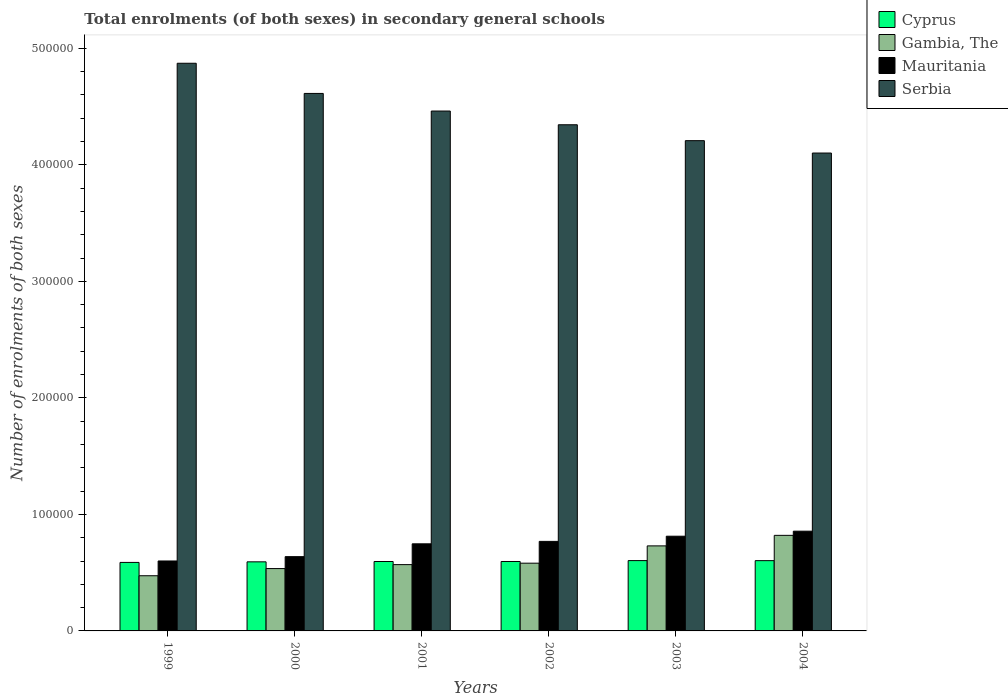How many different coloured bars are there?
Give a very brief answer. 4. How many groups of bars are there?
Your answer should be compact. 6. How many bars are there on the 4th tick from the left?
Offer a terse response. 4. What is the number of enrolments in secondary schools in Mauritania in 2003?
Keep it short and to the point. 8.13e+04. Across all years, what is the maximum number of enrolments in secondary schools in Cyprus?
Ensure brevity in your answer.  6.03e+04. Across all years, what is the minimum number of enrolments in secondary schools in Serbia?
Your answer should be compact. 4.10e+05. What is the total number of enrolments in secondary schools in Cyprus in the graph?
Provide a short and direct response. 3.58e+05. What is the difference between the number of enrolments in secondary schools in Mauritania in 1999 and that in 2000?
Your answer should be very brief. -3706. What is the difference between the number of enrolments in secondary schools in Cyprus in 2000 and the number of enrolments in secondary schools in Serbia in 2004?
Offer a very short reply. -3.51e+05. What is the average number of enrolments in secondary schools in Cyprus per year?
Your answer should be compact. 5.96e+04. In the year 2001, what is the difference between the number of enrolments in secondary schools in Serbia and number of enrolments in secondary schools in Gambia, The?
Ensure brevity in your answer.  3.89e+05. In how many years, is the number of enrolments in secondary schools in Serbia greater than 360000?
Provide a succinct answer. 6. What is the ratio of the number of enrolments in secondary schools in Cyprus in 2000 to that in 2002?
Your answer should be very brief. 1. Is the number of enrolments in secondary schools in Gambia, The in 1999 less than that in 2001?
Provide a succinct answer. Yes. Is the difference between the number of enrolments in secondary schools in Serbia in 2001 and 2003 greater than the difference between the number of enrolments in secondary schools in Gambia, The in 2001 and 2003?
Your answer should be very brief. Yes. What is the difference between the highest and the second highest number of enrolments in secondary schools in Gambia, The?
Provide a succinct answer. 9037. What is the difference between the highest and the lowest number of enrolments in secondary schools in Cyprus?
Provide a succinct answer. 1559. In how many years, is the number of enrolments in secondary schools in Cyprus greater than the average number of enrolments in secondary schools in Cyprus taken over all years?
Your answer should be very brief. 2. Is it the case that in every year, the sum of the number of enrolments in secondary schools in Gambia, The and number of enrolments in secondary schools in Serbia is greater than the sum of number of enrolments in secondary schools in Mauritania and number of enrolments in secondary schools in Cyprus?
Your answer should be very brief. Yes. What does the 4th bar from the left in 2001 represents?
Offer a very short reply. Serbia. What does the 3rd bar from the right in 2002 represents?
Ensure brevity in your answer.  Gambia, The. Are all the bars in the graph horizontal?
Offer a very short reply. No. How many legend labels are there?
Your answer should be compact. 4. What is the title of the graph?
Ensure brevity in your answer.  Total enrolments (of both sexes) in secondary general schools. Does "Small states" appear as one of the legend labels in the graph?
Make the answer very short. No. What is the label or title of the X-axis?
Make the answer very short. Years. What is the label or title of the Y-axis?
Give a very brief answer. Number of enrolments of both sexes. What is the Number of enrolments of both sexes in Cyprus in 1999?
Make the answer very short. 5.88e+04. What is the Number of enrolments of both sexes in Gambia, The in 1999?
Ensure brevity in your answer.  4.74e+04. What is the Number of enrolments of both sexes in Mauritania in 1999?
Give a very brief answer. 6.00e+04. What is the Number of enrolments of both sexes in Serbia in 1999?
Your answer should be very brief. 4.87e+05. What is the Number of enrolments of both sexes in Cyprus in 2000?
Your answer should be very brief. 5.93e+04. What is the Number of enrolments of both sexes of Gambia, The in 2000?
Your answer should be compact. 5.35e+04. What is the Number of enrolments of both sexes of Mauritania in 2000?
Offer a very short reply. 6.37e+04. What is the Number of enrolments of both sexes in Serbia in 2000?
Your response must be concise. 4.61e+05. What is the Number of enrolments of both sexes of Cyprus in 2001?
Your response must be concise. 5.96e+04. What is the Number of enrolments of both sexes of Gambia, The in 2001?
Ensure brevity in your answer.  5.69e+04. What is the Number of enrolments of both sexes of Mauritania in 2001?
Your answer should be compact. 7.47e+04. What is the Number of enrolments of both sexes in Serbia in 2001?
Offer a terse response. 4.46e+05. What is the Number of enrolments of both sexes in Cyprus in 2002?
Ensure brevity in your answer.  5.96e+04. What is the Number of enrolments of both sexes of Gambia, The in 2002?
Your answer should be very brief. 5.81e+04. What is the Number of enrolments of both sexes in Mauritania in 2002?
Your response must be concise. 7.68e+04. What is the Number of enrolments of both sexes of Serbia in 2002?
Keep it short and to the point. 4.34e+05. What is the Number of enrolments of both sexes in Cyprus in 2003?
Your answer should be very brief. 6.03e+04. What is the Number of enrolments of both sexes of Gambia, The in 2003?
Keep it short and to the point. 7.30e+04. What is the Number of enrolments of both sexes in Mauritania in 2003?
Give a very brief answer. 8.13e+04. What is the Number of enrolments of both sexes of Serbia in 2003?
Your answer should be very brief. 4.21e+05. What is the Number of enrolments of both sexes in Cyprus in 2004?
Keep it short and to the point. 6.03e+04. What is the Number of enrolments of both sexes of Gambia, The in 2004?
Offer a terse response. 8.20e+04. What is the Number of enrolments of both sexes of Mauritania in 2004?
Offer a very short reply. 8.56e+04. What is the Number of enrolments of both sexes of Serbia in 2004?
Give a very brief answer. 4.10e+05. Across all years, what is the maximum Number of enrolments of both sexes in Cyprus?
Provide a short and direct response. 6.03e+04. Across all years, what is the maximum Number of enrolments of both sexes of Gambia, The?
Ensure brevity in your answer.  8.20e+04. Across all years, what is the maximum Number of enrolments of both sexes of Mauritania?
Your answer should be compact. 8.56e+04. Across all years, what is the maximum Number of enrolments of both sexes of Serbia?
Your answer should be compact. 4.87e+05. Across all years, what is the minimum Number of enrolments of both sexes in Cyprus?
Your answer should be very brief. 5.88e+04. Across all years, what is the minimum Number of enrolments of both sexes in Gambia, The?
Ensure brevity in your answer.  4.74e+04. Across all years, what is the minimum Number of enrolments of both sexes in Mauritania?
Provide a succinct answer. 6.00e+04. Across all years, what is the minimum Number of enrolments of both sexes in Serbia?
Your answer should be compact. 4.10e+05. What is the total Number of enrolments of both sexes of Cyprus in the graph?
Your answer should be compact. 3.58e+05. What is the total Number of enrolments of both sexes of Gambia, The in the graph?
Your answer should be compact. 3.71e+05. What is the total Number of enrolments of both sexes in Mauritania in the graph?
Offer a very short reply. 4.42e+05. What is the total Number of enrolments of both sexes of Serbia in the graph?
Make the answer very short. 2.66e+06. What is the difference between the Number of enrolments of both sexes of Cyprus in 1999 and that in 2000?
Provide a succinct answer. -496. What is the difference between the Number of enrolments of both sexes in Gambia, The in 1999 and that in 2000?
Your answer should be very brief. -6152. What is the difference between the Number of enrolments of both sexes of Mauritania in 1999 and that in 2000?
Your answer should be very brief. -3706. What is the difference between the Number of enrolments of both sexes in Serbia in 1999 and that in 2000?
Ensure brevity in your answer.  2.59e+04. What is the difference between the Number of enrolments of both sexes in Cyprus in 1999 and that in 2001?
Your response must be concise. -779. What is the difference between the Number of enrolments of both sexes of Gambia, The in 1999 and that in 2001?
Make the answer very short. -9535. What is the difference between the Number of enrolments of both sexes of Mauritania in 1999 and that in 2001?
Your response must be concise. -1.47e+04. What is the difference between the Number of enrolments of both sexes in Serbia in 1999 and that in 2001?
Keep it short and to the point. 4.10e+04. What is the difference between the Number of enrolments of both sexes in Cyprus in 1999 and that in 2002?
Offer a terse response. -792. What is the difference between the Number of enrolments of both sexes in Gambia, The in 1999 and that in 2002?
Offer a terse response. -1.08e+04. What is the difference between the Number of enrolments of both sexes of Mauritania in 1999 and that in 2002?
Offer a very short reply. -1.68e+04. What is the difference between the Number of enrolments of both sexes in Serbia in 1999 and that in 2002?
Provide a short and direct response. 5.28e+04. What is the difference between the Number of enrolments of both sexes of Cyprus in 1999 and that in 2003?
Provide a succinct answer. -1559. What is the difference between the Number of enrolments of both sexes in Gambia, The in 1999 and that in 2003?
Make the answer very short. -2.56e+04. What is the difference between the Number of enrolments of both sexes of Mauritania in 1999 and that in 2003?
Give a very brief answer. -2.12e+04. What is the difference between the Number of enrolments of both sexes in Serbia in 1999 and that in 2003?
Give a very brief answer. 6.64e+04. What is the difference between the Number of enrolments of both sexes of Cyprus in 1999 and that in 2004?
Ensure brevity in your answer.  -1520. What is the difference between the Number of enrolments of both sexes of Gambia, The in 1999 and that in 2004?
Your answer should be compact. -3.47e+04. What is the difference between the Number of enrolments of both sexes in Mauritania in 1999 and that in 2004?
Give a very brief answer. -2.56e+04. What is the difference between the Number of enrolments of both sexes in Serbia in 1999 and that in 2004?
Provide a succinct answer. 7.70e+04. What is the difference between the Number of enrolments of both sexes of Cyprus in 2000 and that in 2001?
Your answer should be compact. -283. What is the difference between the Number of enrolments of both sexes in Gambia, The in 2000 and that in 2001?
Make the answer very short. -3383. What is the difference between the Number of enrolments of both sexes in Mauritania in 2000 and that in 2001?
Your response must be concise. -1.10e+04. What is the difference between the Number of enrolments of both sexes of Serbia in 2000 and that in 2001?
Ensure brevity in your answer.  1.51e+04. What is the difference between the Number of enrolments of both sexes of Cyprus in 2000 and that in 2002?
Make the answer very short. -296. What is the difference between the Number of enrolments of both sexes in Gambia, The in 2000 and that in 2002?
Give a very brief answer. -4617. What is the difference between the Number of enrolments of both sexes in Mauritania in 2000 and that in 2002?
Give a very brief answer. -1.31e+04. What is the difference between the Number of enrolments of both sexes of Serbia in 2000 and that in 2002?
Offer a terse response. 2.69e+04. What is the difference between the Number of enrolments of both sexes of Cyprus in 2000 and that in 2003?
Provide a succinct answer. -1063. What is the difference between the Number of enrolments of both sexes of Gambia, The in 2000 and that in 2003?
Provide a succinct answer. -1.95e+04. What is the difference between the Number of enrolments of both sexes in Mauritania in 2000 and that in 2003?
Provide a short and direct response. -1.75e+04. What is the difference between the Number of enrolments of both sexes in Serbia in 2000 and that in 2003?
Your answer should be very brief. 4.05e+04. What is the difference between the Number of enrolments of both sexes in Cyprus in 2000 and that in 2004?
Your answer should be compact. -1024. What is the difference between the Number of enrolments of both sexes of Gambia, The in 2000 and that in 2004?
Offer a terse response. -2.85e+04. What is the difference between the Number of enrolments of both sexes in Mauritania in 2000 and that in 2004?
Offer a very short reply. -2.19e+04. What is the difference between the Number of enrolments of both sexes of Serbia in 2000 and that in 2004?
Provide a succinct answer. 5.12e+04. What is the difference between the Number of enrolments of both sexes in Cyprus in 2001 and that in 2002?
Provide a short and direct response. -13. What is the difference between the Number of enrolments of both sexes in Gambia, The in 2001 and that in 2002?
Provide a short and direct response. -1234. What is the difference between the Number of enrolments of both sexes of Mauritania in 2001 and that in 2002?
Give a very brief answer. -2095. What is the difference between the Number of enrolments of both sexes of Serbia in 2001 and that in 2002?
Your answer should be compact. 1.18e+04. What is the difference between the Number of enrolments of both sexes in Cyprus in 2001 and that in 2003?
Your response must be concise. -780. What is the difference between the Number of enrolments of both sexes in Gambia, The in 2001 and that in 2003?
Offer a very short reply. -1.61e+04. What is the difference between the Number of enrolments of both sexes in Mauritania in 2001 and that in 2003?
Your response must be concise. -6536. What is the difference between the Number of enrolments of both sexes of Serbia in 2001 and that in 2003?
Your answer should be very brief. 2.54e+04. What is the difference between the Number of enrolments of both sexes of Cyprus in 2001 and that in 2004?
Offer a terse response. -741. What is the difference between the Number of enrolments of both sexes of Gambia, The in 2001 and that in 2004?
Make the answer very short. -2.51e+04. What is the difference between the Number of enrolments of both sexes of Mauritania in 2001 and that in 2004?
Offer a terse response. -1.08e+04. What is the difference between the Number of enrolments of both sexes in Serbia in 2001 and that in 2004?
Keep it short and to the point. 3.60e+04. What is the difference between the Number of enrolments of both sexes in Cyprus in 2002 and that in 2003?
Your answer should be compact. -767. What is the difference between the Number of enrolments of both sexes in Gambia, The in 2002 and that in 2003?
Give a very brief answer. -1.48e+04. What is the difference between the Number of enrolments of both sexes of Mauritania in 2002 and that in 2003?
Provide a succinct answer. -4441. What is the difference between the Number of enrolments of both sexes of Serbia in 2002 and that in 2003?
Your answer should be very brief. 1.36e+04. What is the difference between the Number of enrolments of both sexes in Cyprus in 2002 and that in 2004?
Ensure brevity in your answer.  -728. What is the difference between the Number of enrolments of both sexes of Gambia, The in 2002 and that in 2004?
Your response must be concise. -2.39e+04. What is the difference between the Number of enrolments of both sexes of Mauritania in 2002 and that in 2004?
Your answer should be very brief. -8751. What is the difference between the Number of enrolments of both sexes in Serbia in 2002 and that in 2004?
Provide a short and direct response. 2.43e+04. What is the difference between the Number of enrolments of both sexes in Cyprus in 2003 and that in 2004?
Make the answer very short. 39. What is the difference between the Number of enrolments of both sexes of Gambia, The in 2003 and that in 2004?
Your answer should be very brief. -9037. What is the difference between the Number of enrolments of both sexes in Mauritania in 2003 and that in 2004?
Make the answer very short. -4310. What is the difference between the Number of enrolments of both sexes in Serbia in 2003 and that in 2004?
Offer a very short reply. 1.06e+04. What is the difference between the Number of enrolments of both sexes of Cyprus in 1999 and the Number of enrolments of both sexes of Gambia, The in 2000?
Offer a terse response. 5279. What is the difference between the Number of enrolments of both sexes in Cyprus in 1999 and the Number of enrolments of both sexes in Mauritania in 2000?
Make the answer very short. -4946. What is the difference between the Number of enrolments of both sexes in Cyprus in 1999 and the Number of enrolments of both sexes in Serbia in 2000?
Your response must be concise. -4.02e+05. What is the difference between the Number of enrolments of both sexes of Gambia, The in 1999 and the Number of enrolments of both sexes of Mauritania in 2000?
Give a very brief answer. -1.64e+04. What is the difference between the Number of enrolments of both sexes in Gambia, The in 1999 and the Number of enrolments of both sexes in Serbia in 2000?
Provide a succinct answer. -4.14e+05. What is the difference between the Number of enrolments of both sexes of Mauritania in 1999 and the Number of enrolments of both sexes of Serbia in 2000?
Your answer should be very brief. -4.01e+05. What is the difference between the Number of enrolments of both sexes in Cyprus in 1999 and the Number of enrolments of both sexes in Gambia, The in 2001?
Make the answer very short. 1896. What is the difference between the Number of enrolments of both sexes in Cyprus in 1999 and the Number of enrolments of both sexes in Mauritania in 2001?
Make the answer very short. -1.60e+04. What is the difference between the Number of enrolments of both sexes of Cyprus in 1999 and the Number of enrolments of both sexes of Serbia in 2001?
Your answer should be compact. -3.87e+05. What is the difference between the Number of enrolments of both sexes in Gambia, The in 1999 and the Number of enrolments of both sexes in Mauritania in 2001?
Provide a short and direct response. -2.74e+04. What is the difference between the Number of enrolments of both sexes of Gambia, The in 1999 and the Number of enrolments of both sexes of Serbia in 2001?
Ensure brevity in your answer.  -3.99e+05. What is the difference between the Number of enrolments of both sexes of Mauritania in 1999 and the Number of enrolments of both sexes of Serbia in 2001?
Your response must be concise. -3.86e+05. What is the difference between the Number of enrolments of both sexes in Cyprus in 1999 and the Number of enrolments of both sexes in Gambia, The in 2002?
Your answer should be very brief. 662. What is the difference between the Number of enrolments of both sexes of Cyprus in 1999 and the Number of enrolments of both sexes of Mauritania in 2002?
Give a very brief answer. -1.80e+04. What is the difference between the Number of enrolments of both sexes in Cyprus in 1999 and the Number of enrolments of both sexes in Serbia in 2002?
Make the answer very short. -3.76e+05. What is the difference between the Number of enrolments of both sexes in Gambia, The in 1999 and the Number of enrolments of both sexes in Mauritania in 2002?
Give a very brief answer. -2.95e+04. What is the difference between the Number of enrolments of both sexes of Gambia, The in 1999 and the Number of enrolments of both sexes of Serbia in 2002?
Offer a terse response. -3.87e+05. What is the difference between the Number of enrolments of both sexes of Mauritania in 1999 and the Number of enrolments of both sexes of Serbia in 2002?
Make the answer very short. -3.74e+05. What is the difference between the Number of enrolments of both sexes of Cyprus in 1999 and the Number of enrolments of both sexes of Gambia, The in 2003?
Keep it short and to the point. -1.42e+04. What is the difference between the Number of enrolments of both sexes in Cyprus in 1999 and the Number of enrolments of both sexes in Mauritania in 2003?
Provide a succinct answer. -2.25e+04. What is the difference between the Number of enrolments of both sexes in Cyprus in 1999 and the Number of enrolments of both sexes in Serbia in 2003?
Ensure brevity in your answer.  -3.62e+05. What is the difference between the Number of enrolments of both sexes of Gambia, The in 1999 and the Number of enrolments of both sexes of Mauritania in 2003?
Ensure brevity in your answer.  -3.39e+04. What is the difference between the Number of enrolments of both sexes of Gambia, The in 1999 and the Number of enrolments of both sexes of Serbia in 2003?
Your answer should be very brief. -3.73e+05. What is the difference between the Number of enrolments of both sexes of Mauritania in 1999 and the Number of enrolments of both sexes of Serbia in 2003?
Your response must be concise. -3.61e+05. What is the difference between the Number of enrolments of both sexes in Cyprus in 1999 and the Number of enrolments of both sexes in Gambia, The in 2004?
Ensure brevity in your answer.  -2.32e+04. What is the difference between the Number of enrolments of both sexes in Cyprus in 1999 and the Number of enrolments of both sexes in Mauritania in 2004?
Provide a succinct answer. -2.68e+04. What is the difference between the Number of enrolments of both sexes in Cyprus in 1999 and the Number of enrolments of both sexes in Serbia in 2004?
Make the answer very short. -3.51e+05. What is the difference between the Number of enrolments of both sexes of Gambia, The in 1999 and the Number of enrolments of both sexes of Mauritania in 2004?
Offer a very short reply. -3.82e+04. What is the difference between the Number of enrolments of both sexes in Gambia, The in 1999 and the Number of enrolments of both sexes in Serbia in 2004?
Provide a succinct answer. -3.63e+05. What is the difference between the Number of enrolments of both sexes of Mauritania in 1999 and the Number of enrolments of both sexes of Serbia in 2004?
Give a very brief answer. -3.50e+05. What is the difference between the Number of enrolments of both sexes in Cyprus in 2000 and the Number of enrolments of both sexes in Gambia, The in 2001?
Ensure brevity in your answer.  2392. What is the difference between the Number of enrolments of both sexes of Cyprus in 2000 and the Number of enrolments of both sexes of Mauritania in 2001?
Your response must be concise. -1.55e+04. What is the difference between the Number of enrolments of both sexes in Cyprus in 2000 and the Number of enrolments of both sexes in Serbia in 2001?
Keep it short and to the point. -3.87e+05. What is the difference between the Number of enrolments of both sexes of Gambia, The in 2000 and the Number of enrolments of both sexes of Mauritania in 2001?
Offer a very short reply. -2.12e+04. What is the difference between the Number of enrolments of both sexes of Gambia, The in 2000 and the Number of enrolments of both sexes of Serbia in 2001?
Ensure brevity in your answer.  -3.93e+05. What is the difference between the Number of enrolments of both sexes in Mauritania in 2000 and the Number of enrolments of both sexes in Serbia in 2001?
Provide a short and direct response. -3.82e+05. What is the difference between the Number of enrolments of both sexes in Cyprus in 2000 and the Number of enrolments of both sexes in Gambia, The in 2002?
Provide a short and direct response. 1158. What is the difference between the Number of enrolments of both sexes of Cyprus in 2000 and the Number of enrolments of both sexes of Mauritania in 2002?
Your response must be concise. -1.76e+04. What is the difference between the Number of enrolments of both sexes of Cyprus in 2000 and the Number of enrolments of both sexes of Serbia in 2002?
Offer a terse response. -3.75e+05. What is the difference between the Number of enrolments of both sexes in Gambia, The in 2000 and the Number of enrolments of both sexes in Mauritania in 2002?
Provide a succinct answer. -2.33e+04. What is the difference between the Number of enrolments of both sexes of Gambia, The in 2000 and the Number of enrolments of both sexes of Serbia in 2002?
Offer a terse response. -3.81e+05. What is the difference between the Number of enrolments of both sexes in Mauritania in 2000 and the Number of enrolments of both sexes in Serbia in 2002?
Offer a very short reply. -3.71e+05. What is the difference between the Number of enrolments of both sexes in Cyprus in 2000 and the Number of enrolments of both sexes in Gambia, The in 2003?
Your answer should be compact. -1.37e+04. What is the difference between the Number of enrolments of both sexes in Cyprus in 2000 and the Number of enrolments of both sexes in Mauritania in 2003?
Offer a very short reply. -2.20e+04. What is the difference between the Number of enrolments of both sexes of Cyprus in 2000 and the Number of enrolments of both sexes of Serbia in 2003?
Provide a succinct answer. -3.61e+05. What is the difference between the Number of enrolments of both sexes in Gambia, The in 2000 and the Number of enrolments of both sexes in Mauritania in 2003?
Keep it short and to the point. -2.78e+04. What is the difference between the Number of enrolments of both sexes in Gambia, The in 2000 and the Number of enrolments of both sexes in Serbia in 2003?
Offer a very short reply. -3.67e+05. What is the difference between the Number of enrolments of both sexes of Mauritania in 2000 and the Number of enrolments of both sexes of Serbia in 2003?
Provide a succinct answer. -3.57e+05. What is the difference between the Number of enrolments of both sexes of Cyprus in 2000 and the Number of enrolments of both sexes of Gambia, The in 2004?
Offer a terse response. -2.27e+04. What is the difference between the Number of enrolments of both sexes of Cyprus in 2000 and the Number of enrolments of both sexes of Mauritania in 2004?
Your answer should be very brief. -2.63e+04. What is the difference between the Number of enrolments of both sexes in Cyprus in 2000 and the Number of enrolments of both sexes in Serbia in 2004?
Your response must be concise. -3.51e+05. What is the difference between the Number of enrolments of both sexes of Gambia, The in 2000 and the Number of enrolments of both sexes of Mauritania in 2004?
Offer a very short reply. -3.21e+04. What is the difference between the Number of enrolments of both sexes of Gambia, The in 2000 and the Number of enrolments of both sexes of Serbia in 2004?
Give a very brief answer. -3.57e+05. What is the difference between the Number of enrolments of both sexes in Mauritania in 2000 and the Number of enrolments of both sexes in Serbia in 2004?
Ensure brevity in your answer.  -3.46e+05. What is the difference between the Number of enrolments of both sexes of Cyprus in 2001 and the Number of enrolments of both sexes of Gambia, The in 2002?
Your response must be concise. 1441. What is the difference between the Number of enrolments of both sexes in Cyprus in 2001 and the Number of enrolments of both sexes in Mauritania in 2002?
Your answer should be very brief. -1.73e+04. What is the difference between the Number of enrolments of both sexes of Cyprus in 2001 and the Number of enrolments of both sexes of Serbia in 2002?
Your response must be concise. -3.75e+05. What is the difference between the Number of enrolments of both sexes of Gambia, The in 2001 and the Number of enrolments of both sexes of Mauritania in 2002?
Give a very brief answer. -1.99e+04. What is the difference between the Number of enrolments of both sexes of Gambia, The in 2001 and the Number of enrolments of both sexes of Serbia in 2002?
Offer a very short reply. -3.77e+05. What is the difference between the Number of enrolments of both sexes in Mauritania in 2001 and the Number of enrolments of both sexes in Serbia in 2002?
Keep it short and to the point. -3.60e+05. What is the difference between the Number of enrolments of both sexes of Cyprus in 2001 and the Number of enrolments of both sexes of Gambia, The in 2003?
Your answer should be compact. -1.34e+04. What is the difference between the Number of enrolments of both sexes in Cyprus in 2001 and the Number of enrolments of both sexes in Mauritania in 2003?
Keep it short and to the point. -2.17e+04. What is the difference between the Number of enrolments of both sexes in Cyprus in 2001 and the Number of enrolments of both sexes in Serbia in 2003?
Make the answer very short. -3.61e+05. What is the difference between the Number of enrolments of both sexes of Gambia, The in 2001 and the Number of enrolments of both sexes of Mauritania in 2003?
Make the answer very short. -2.44e+04. What is the difference between the Number of enrolments of both sexes of Gambia, The in 2001 and the Number of enrolments of both sexes of Serbia in 2003?
Offer a very short reply. -3.64e+05. What is the difference between the Number of enrolments of both sexes in Mauritania in 2001 and the Number of enrolments of both sexes in Serbia in 2003?
Provide a succinct answer. -3.46e+05. What is the difference between the Number of enrolments of both sexes in Cyprus in 2001 and the Number of enrolments of both sexes in Gambia, The in 2004?
Provide a succinct answer. -2.24e+04. What is the difference between the Number of enrolments of both sexes of Cyprus in 2001 and the Number of enrolments of both sexes of Mauritania in 2004?
Your answer should be compact. -2.60e+04. What is the difference between the Number of enrolments of both sexes in Cyprus in 2001 and the Number of enrolments of both sexes in Serbia in 2004?
Provide a succinct answer. -3.51e+05. What is the difference between the Number of enrolments of both sexes in Gambia, The in 2001 and the Number of enrolments of both sexes in Mauritania in 2004?
Your answer should be compact. -2.87e+04. What is the difference between the Number of enrolments of both sexes of Gambia, The in 2001 and the Number of enrolments of both sexes of Serbia in 2004?
Keep it short and to the point. -3.53e+05. What is the difference between the Number of enrolments of both sexes in Mauritania in 2001 and the Number of enrolments of both sexes in Serbia in 2004?
Ensure brevity in your answer.  -3.35e+05. What is the difference between the Number of enrolments of both sexes in Cyprus in 2002 and the Number of enrolments of both sexes in Gambia, The in 2003?
Your response must be concise. -1.34e+04. What is the difference between the Number of enrolments of both sexes in Cyprus in 2002 and the Number of enrolments of both sexes in Mauritania in 2003?
Your answer should be compact. -2.17e+04. What is the difference between the Number of enrolments of both sexes in Cyprus in 2002 and the Number of enrolments of both sexes in Serbia in 2003?
Give a very brief answer. -3.61e+05. What is the difference between the Number of enrolments of both sexes of Gambia, The in 2002 and the Number of enrolments of both sexes of Mauritania in 2003?
Your answer should be compact. -2.32e+04. What is the difference between the Number of enrolments of both sexes of Gambia, The in 2002 and the Number of enrolments of both sexes of Serbia in 2003?
Provide a short and direct response. -3.63e+05. What is the difference between the Number of enrolments of both sexes in Mauritania in 2002 and the Number of enrolments of both sexes in Serbia in 2003?
Keep it short and to the point. -3.44e+05. What is the difference between the Number of enrolments of both sexes in Cyprus in 2002 and the Number of enrolments of both sexes in Gambia, The in 2004?
Provide a succinct answer. -2.24e+04. What is the difference between the Number of enrolments of both sexes in Cyprus in 2002 and the Number of enrolments of both sexes in Mauritania in 2004?
Offer a very short reply. -2.60e+04. What is the difference between the Number of enrolments of both sexes of Cyprus in 2002 and the Number of enrolments of both sexes of Serbia in 2004?
Ensure brevity in your answer.  -3.51e+05. What is the difference between the Number of enrolments of both sexes in Gambia, The in 2002 and the Number of enrolments of both sexes in Mauritania in 2004?
Make the answer very short. -2.75e+04. What is the difference between the Number of enrolments of both sexes in Gambia, The in 2002 and the Number of enrolments of both sexes in Serbia in 2004?
Give a very brief answer. -3.52e+05. What is the difference between the Number of enrolments of both sexes in Mauritania in 2002 and the Number of enrolments of both sexes in Serbia in 2004?
Provide a short and direct response. -3.33e+05. What is the difference between the Number of enrolments of both sexes of Cyprus in 2003 and the Number of enrolments of both sexes of Gambia, The in 2004?
Offer a terse response. -2.17e+04. What is the difference between the Number of enrolments of both sexes of Cyprus in 2003 and the Number of enrolments of both sexes of Mauritania in 2004?
Your response must be concise. -2.52e+04. What is the difference between the Number of enrolments of both sexes in Cyprus in 2003 and the Number of enrolments of both sexes in Serbia in 2004?
Your answer should be very brief. -3.50e+05. What is the difference between the Number of enrolments of both sexes of Gambia, The in 2003 and the Number of enrolments of both sexes of Mauritania in 2004?
Give a very brief answer. -1.26e+04. What is the difference between the Number of enrolments of both sexes in Gambia, The in 2003 and the Number of enrolments of both sexes in Serbia in 2004?
Provide a short and direct response. -3.37e+05. What is the difference between the Number of enrolments of both sexes in Mauritania in 2003 and the Number of enrolments of both sexes in Serbia in 2004?
Ensure brevity in your answer.  -3.29e+05. What is the average Number of enrolments of both sexes of Cyprus per year?
Provide a succinct answer. 5.96e+04. What is the average Number of enrolments of both sexes of Gambia, The per year?
Your answer should be very brief. 6.18e+04. What is the average Number of enrolments of both sexes in Mauritania per year?
Provide a succinct answer. 7.37e+04. What is the average Number of enrolments of both sexes of Serbia per year?
Your answer should be very brief. 4.43e+05. In the year 1999, what is the difference between the Number of enrolments of both sexes in Cyprus and Number of enrolments of both sexes in Gambia, The?
Keep it short and to the point. 1.14e+04. In the year 1999, what is the difference between the Number of enrolments of both sexes in Cyprus and Number of enrolments of both sexes in Mauritania?
Provide a short and direct response. -1240. In the year 1999, what is the difference between the Number of enrolments of both sexes in Cyprus and Number of enrolments of both sexes in Serbia?
Offer a very short reply. -4.28e+05. In the year 1999, what is the difference between the Number of enrolments of both sexes of Gambia, The and Number of enrolments of both sexes of Mauritania?
Your answer should be very brief. -1.27e+04. In the year 1999, what is the difference between the Number of enrolments of both sexes in Gambia, The and Number of enrolments of both sexes in Serbia?
Your response must be concise. -4.40e+05. In the year 1999, what is the difference between the Number of enrolments of both sexes in Mauritania and Number of enrolments of both sexes in Serbia?
Provide a succinct answer. -4.27e+05. In the year 2000, what is the difference between the Number of enrolments of both sexes in Cyprus and Number of enrolments of both sexes in Gambia, The?
Offer a very short reply. 5775. In the year 2000, what is the difference between the Number of enrolments of both sexes in Cyprus and Number of enrolments of both sexes in Mauritania?
Your response must be concise. -4450. In the year 2000, what is the difference between the Number of enrolments of both sexes of Cyprus and Number of enrolments of both sexes of Serbia?
Provide a short and direct response. -4.02e+05. In the year 2000, what is the difference between the Number of enrolments of both sexes of Gambia, The and Number of enrolments of both sexes of Mauritania?
Provide a succinct answer. -1.02e+04. In the year 2000, what is the difference between the Number of enrolments of both sexes of Gambia, The and Number of enrolments of both sexes of Serbia?
Make the answer very short. -4.08e+05. In the year 2000, what is the difference between the Number of enrolments of both sexes of Mauritania and Number of enrolments of both sexes of Serbia?
Provide a succinct answer. -3.98e+05. In the year 2001, what is the difference between the Number of enrolments of both sexes of Cyprus and Number of enrolments of both sexes of Gambia, The?
Offer a very short reply. 2675. In the year 2001, what is the difference between the Number of enrolments of both sexes in Cyprus and Number of enrolments of both sexes in Mauritania?
Offer a terse response. -1.52e+04. In the year 2001, what is the difference between the Number of enrolments of both sexes of Cyprus and Number of enrolments of both sexes of Serbia?
Offer a very short reply. -3.87e+05. In the year 2001, what is the difference between the Number of enrolments of both sexes in Gambia, The and Number of enrolments of both sexes in Mauritania?
Provide a succinct answer. -1.78e+04. In the year 2001, what is the difference between the Number of enrolments of both sexes of Gambia, The and Number of enrolments of both sexes of Serbia?
Your answer should be very brief. -3.89e+05. In the year 2001, what is the difference between the Number of enrolments of both sexes of Mauritania and Number of enrolments of both sexes of Serbia?
Offer a very short reply. -3.71e+05. In the year 2002, what is the difference between the Number of enrolments of both sexes of Cyprus and Number of enrolments of both sexes of Gambia, The?
Provide a succinct answer. 1454. In the year 2002, what is the difference between the Number of enrolments of both sexes of Cyprus and Number of enrolments of both sexes of Mauritania?
Keep it short and to the point. -1.73e+04. In the year 2002, what is the difference between the Number of enrolments of both sexes in Cyprus and Number of enrolments of both sexes in Serbia?
Ensure brevity in your answer.  -3.75e+05. In the year 2002, what is the difference between the Number of enrolments of both sexes of Gambia, The and Number of enrolments of both sexes of Mauritania?
Offer a terse response. -1.87e+04. In the year 2002, what is the difference between the Number of enrolments of both sexes in Gambia, The and Number of enrolments of both sexes in Serbia?
Your answer should be compact. -3.76e+05. In the year 2002, what is the difference between the Number of enrolments of both sexes of Mauritania and Number of enrolments of both sexes of Serbia?
Provide a succinct answer. -3.58e+05. In the year 2003, what is the difference between the Number of enrolments of both sexes of Cyprus and Number of enrolments of both sexes of Gambia, The?
Keep it short and to the point. -1.26e+04. In the year 2003, what is the difference between the Number of enrolments of both sexes in Cyprus and Number of enrolments of both sexes in Mauritania?
Offer a very short reply. -2.09e+04. In the year 2003, what is the difference between the Number of enrolments of both sexes in Cyprus and Number of enrolments of both sexes in Serbia?
Your response must be concise. -3.60e+05. In the year 2003, what is the difference between the Number of enrolments of both sexes in Gambia, The and Number of enrolments of both sexes in Mauritania?
Your response must be concise. -8301. In the year 2003, what is the difference between the Number of enrolments of both sexes of Gambia, The and Number of enrolments of both sexes of Serbia?
Give a very brief answer. -3.48e+05. In the year 2003, what is the difference between the Number of enrolments of both sexes in Mauritania and Number of enrolments of both sexes in Serbia?
Your answer should be very brief. -3.39e+05. In the year 2004, what is the difference between the Number of enrolments of both sexes in Cyprus and Number of enrolments of both sexes in Gambia, The?
Your answer should be compact. -2.17e+04. In the year 2004, what is the difference between the Number of enrolments of both sexes of Cyprus and Number of enrolments of both sexes of Mauritania?
Provide a succinct answer. -2.53e+04. In the year 2004, what is the difference between the Number of enrolments of both sexes of Cyprus and Number of enrolments of both sexes of Serbia?
Keep it short and to the point. -3.50e+05. In the year 2004, what is the difference between the Number of enrolments of both sexes of Gambia, The and Number of enrolments of both sexes of Mauritania?
Offer a very short reply. -3574. In the year 2004, what is the difference between the Number of enrolments of both sexes of Gambia, The and Number of enrolments of both sexes of Serbia?
Your response must be concise. -3.28e+05. In the year 2004, what is the difference between the Number of enrolments of both sexes in Mauritania and Number of enrolments of both sexes in Serbia?
Offer a terse response. -3.25e+05. What is the ratio of the Number of enrolments of both sexes in Cyprus in 1999 to that in 2000?
Keep it short and to the point. 0.99. What is the ratio of the Number of enrolments of both sexes in Gambia, The in 1999 to that in 2000?
Your response must be concise. 0.89. What is the ratio of the Number of enrolments of both sexes of Mauritania in 1999 to that in 2000?
Your response must be concise. 0.94. What is the ratio of the Number of enrolments of both sexes in Serbia in 1999 to that in 2000?
Your response must be concise. 1.06. What is the ratio of the Number of enrolments of both sexes of Cyprus in 1999 to that in 2001?
Provide a succinct answer. 0.99. What is the ratio of the Number of enrolments of both sexes of Gambia, The in 1999 to that in 2001?
Provide a short and direct response. 0.83. What is the ratio of the Number of enrolments of both sexes in Mauritania in 1999 to that in 2001?
Offer a very short reply. 0.8. What is the ratio of the Number of enrolments of both sexes in Serbia in 1999 to that in 2001?
Your response must be concise. 1.09. What is the ratio of the Number of enrolments of both sexes of Cyprus in 1999 to that in 2002?
Give a very brief answer. 0.99. What is the ratio of the Number of enrolments of both sexes in Gambia, The in 1999 to that in 2002?
Make the answer very short. 0.81. What is the ratio of the Number of enrolments of both sexes in Mauritania in 1999 to that in 2002?
Offer a terse response. 0.78. What is the ratio of the Number of enrolments of both sexes in Serbia in 1999 to that in 2002?
Provide a short and direct response. 1.12. What is the ratio of the Number of enrolments of both sexes in Cyprus in 1999 to that in 2003?
Provide a short and direct response. 0.97. What is the ratio of the Number of enrolments of both sexes in Gambia, The in 1999 to that in 2003?
Offer a very short reply. 0.65. What is the ratio of the Number of enrolments of both sexes in Mauritania in 1999 to that in 2003?
Keep it short and to the point. 0.74. What is the ratio of the Number of enrolments of both sexes of Serbia in 1999 to that in 2003?
Provide a short and direct response. 1.16. What is the ratio of the Number of enrolments of both sexes in Cyprus in 1999 to that in 2004?
Make the answer very short. 0.97. What is the ratio of the Number of enrolments of both sexes in Gambia, The in 1999 to that in 2004?
Give a very brief answer. 0.58. What is the ratio of the Number of enrolments of both sexes of Mauritania in 1999 to that in 2004?
Provide a short and direct response. 0.7. What is the ratio of the Number of enrolments of both sexes of Serbia in 1999 to that in 2004?
Offer a terse response. 1.19. What is the ratio of the Number of enrolments of both sexes in Cyprus in 2000 to that in 2001?
Keep it short and to the point. 1. What is the ratio of the Number of enrolments of both sexes in Gambia, The in 2000 to that in 2001?
Provide a succinct answer. 0.94. What is the ratio of the Number of enrolments of both sexes in Mauritania in 2000 to that in 2001?
Ensure brevity in your answer.  0.85. What is the ratio of the Number of enrolments of both sexes in Serbia in 2000 to that in 2001?
Your answer should be very brief. 1.03. What is the ratio of the Number of enrolments of both sexes in Gambia, The in 2000 to that in 2002?
Ensure brevity in your answer.  0.92. What is the ratio of the Number of enrolments of both sexes in Mauritania in 2000 to that in 2002?
Offer a terse response. 0.83. What is the ratio of the Number of enrolments of both sexes in Serbia in 2000 to that in 2002?
Ensure brevity in your answer.  1.06. What is the ratio of the Number of enrolments of both sexes in Cyprus in 2000 to that in 2003?
Provide a succinct answer. 0.98. What is the ratio of the Number of enrolments of both sexes in Gambia, The in 2000 to that in 2003?
Your answer should be compact. 0.73. What is the ratio of the Number of enrolments of both sexes in Mauritania in 2000 to that in 2003?
Your answer should be compact. 0.78. What is the ratio of the Number of enrolments of both sexes of Serbia in 2000 to that in 2003?
Offer a terse response. 1.1. What is the ratio of the Number of enrolments of both sexes in Gambia, The in 2000 to that in 2004?
Ensure brevity in your answer.  0.65. What is the ratio of the Number of enrolments of both sexes in Mauritania in 2000 to that in 2004?
Your response must be concise. 0.74. What is the ratio of the Number of enrolments of both sexes in Serbia in 2000 to that in 2004?
Your answer should be very brief. 1.12. What is the ratio of the Number of enrolments of both sexes of Gambia, The in 2001 to that in 2002?
Your response must be concise. 0.98. What is the ratio of the Number of enrolments of both sexes in Mauritania in 2001 to that in 2002?
Your answer should be very brief. 0.97. What is the ratio of the Number of enrolments of both sexes in Serbia in 2001 to that in 2002?
Give a very brief answer. 1.03. What is the ratio of the Number of enrolments of both sexes of Cyprus in 2001 to that in 2003?
Give a very brief answer. 0.99. What is the ratio of the Number of enrolments of both sexes of Gambia, The in 2001 to that in 2003?
Your answer should be very brief. 0.78. What is the ratio of the Number of enrolments of both sexes in Mauritania in 2001 to that in 2003?
Ensure brevity in your answer.  0.92. What is the ratio of the Number of enrolments of both sexes of Serbia in 2001 to that in 2003?
Give a very brief answer. 1.06. What is the ratio of the Number of enrolments of both sexes of Cyprus in 2001 to that in 2004?
Give a very brief answer. 0.99. What is the ratio of the Number of enrolments of both sexes of Gambia, The in 2001 to that in 2004?
Offer a very short reply. 0.69. What is the ratio of the Number of enrolments of both sexes of Mauritania in 2001 to that in 2004?
Provide a succinct answer. 0.87. What is the ratio of the Number of enrolments of both sexes in Serbia in 2001 to that in 2004?
Make the answer very short. 1.09. What is the ratio of the Number of enrolments of both sexes in Cyprus in 2002 to that in 2003?
Make the answer very short. 0.99. What is the ratio of the Number of enrolments of both sexes in Gambia, The in 2002 to that in 2003?
Provide a short and direct response. 0.8. What is the ratio of the Number of enrolments of both sexes in Mauritania in 2002 to that in 2003?
Keep it short and to the point. 0.95. What is the ratio of the Number of enrolments of both sexes of Serbia in 2002 to that in 2003?
Your answer should be compact. 1.03. What is the ratio of the Number of enrolments of both sexes in Cyprus in 2002 to that in 2004?
Provide a short and direct response. 0.99. What is the ratio of the Number of enrolments of both sexes in Gambia, The in 2002 to that in 2004?
Provide a succinct answer. 0.71. What is the ratio of the Number of enrolments of both sexes in Mauritania in 2002 to that in 2004?
Your answer should be compact. 0.9. What is the ratio of the Number of enrolments of both sexes in Serbia in 2002 to that in 2004?
Make the answer very short. 1.06. What is the ratio of the Number of enrolments of both sexes in Cyprus in 2003 to that in 2004?
Give a very brief answer. 1. What is the ratio of the Number of enrolments of both sexes of Gambia, The in 2003 to that in 2004?
Offer a very short reply. 0.89. What is the ratio of the Number of enrolments of both sexes of Mauritania in 2003 to that in 2004?
Keep it short and to the point. 0.95. What is the ratio of the Number of enrolments of both sexes of Serbia in 2003 to that in 2004?
Make the answer very short. 1.03. What is the difference between the highest and the second highest Number of enrolments of both sexes in Gambia, The?
Offer a terse response. 9037. What is the difference between the highest and the second highest Number of enrolments of both sexes in Mauritania?
Your answer should be very brief. 4310. What is the difference between the highest and the second highest Number of enrolments of both sexes in Serbia?
Make the answer very short. 2.59e+04. What is the difference between the highest and the lowest Number of enrolments of both sexes in Cyprus?
Ensure brevity in your answer.  1559. What is the difference between the highest and the lowest Number of enrolments of both sexes in Gambia, The?
Make the answer very short. 3.47e+04. What is the difference between the highest and the lowest Number of enrolments of both sexes in Mauritania?
Your answer should be compact. 2.56e+04. What is the difference between the highest and the lowest Number of enrolments of both sexes of Serbia?
Offer a very short reply. 7.70e+04. 